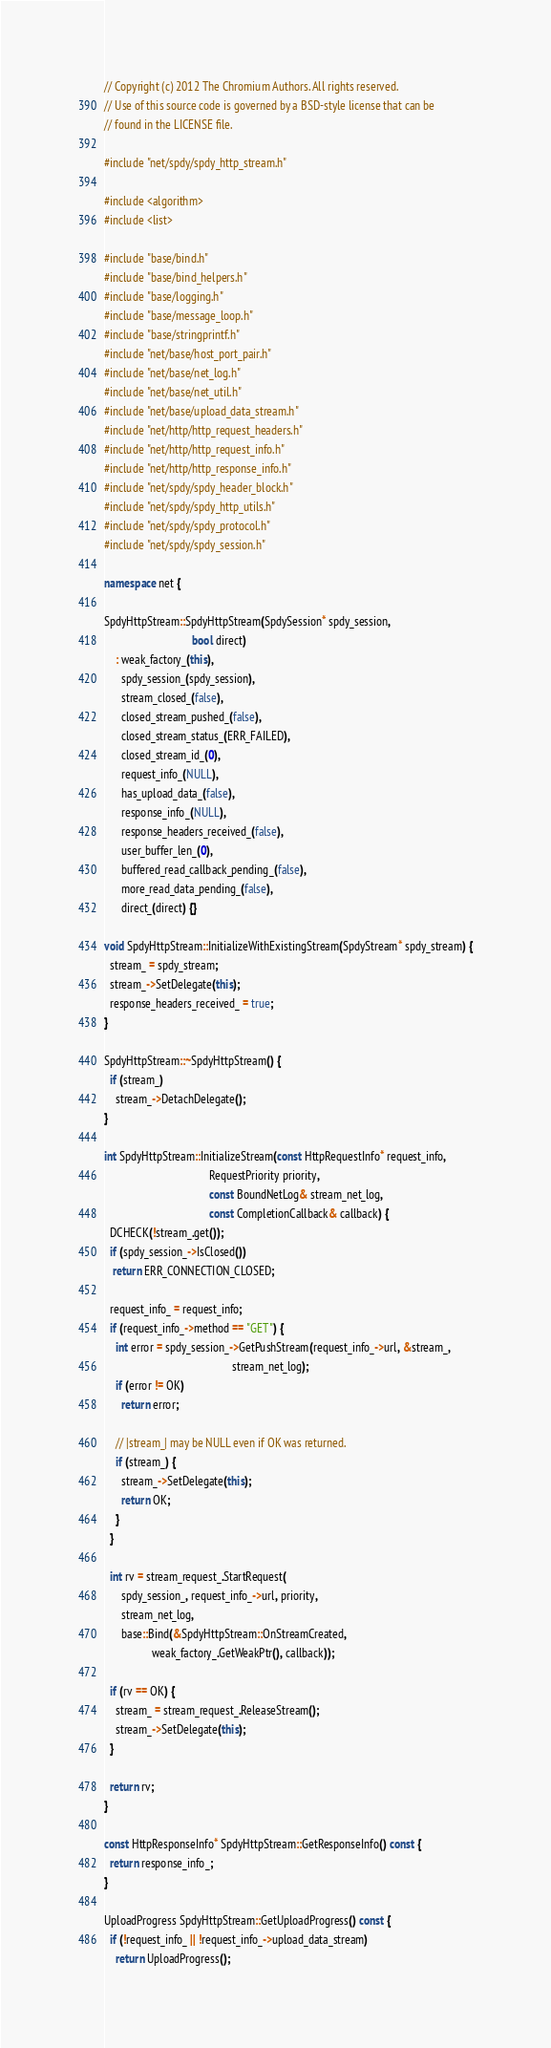<code> <loc_0><loc_0><loc_500><loc_500><_C++_>// Copyright (c) 2012 The Chromium Authors. All rights reserved.
// Use of this source code is governed by a BSD-style license that can be
// found in the LICENSE file.

#include "net/spdy/spdy_http_stream.h"

#include <algorithm>
#include <list>

#include "base/bind.h"
#include "base/bind_helpers.h"
#include "base/logging.h"
#include "base/message_loop.h"
#include "base/stringprintf.h"
#include "net/base/host_port_pair.h"
#include "net/base/net_log.h"
#include "net/base/net_util.h"
#include "net/base/upload_data_stream.h"
#include "net/http/http_request_headers.h"
#include "net/http/http_request_info.h"
#include "net/http/http_response_info.h"
#include "net/spdy/spdy_header_block.h"
#include "net/spdy/spdy_http_utils.h"
#include "net/spdy/spdy_protocol.h"
#include "net/spdy/spdy_session.h"

namespace net {

SpdyHttpStream::SpdyHttpStream(SpdySession* spdy_session,
                               bool direct)
    : weak_factory_(this),
      spdy_session_(spdy_session),
      stream_closed_(false),
      closed_stream_pushed_(false),
      closed_stream_status_(ERR_FAILED),
      closed_stream_id_(0),
      request_info_(NULL),
      has_upload_data_(false),
      response_info_(NULL),
      response_headers_received_(false),
      user_buffer_len_(0),
      buffered_read_callback_pending_(false),
      more_read_data_pending_(false),
      direct_(direct) {}

void SpdyHttpStream::InitializeWithExistingStream(SpdyStream* spdy_stream) {
  stream_ = spdy_stream;
  stream_->SetDelegate(this);
  response_headers_received_ = true;
}

SpdyHttpStream::~SpdyHttpStream() {
  if (stream_)
    stream_->DetachDelegate();
}

int SpdyHttpStream::InitializeStream(const HttpRequestInfo* request_info,
                                     RequestPriority priority,
                                     const BoundNetLog& stream_net_log,
                                     const CompletionCallback& callback) {
  DCHECK(!stream_.get());
  if (spdy_session_->IsClosed())
   return ERR_CONNECTION_CLOSED;

  request_info_ = request_info;
  if (request_info_->method == "GET") {
    int error = spdy_session_->GetPushStream(request_info_->url, &stream_,
                                             stream_net_log);
    if (error != OK)
      return error;

    // |stream_| may be NULL even if OK was returned.
    if (stream_) {
      stream_->SetDelegate(this);
      return OK;
    }
  }

  int rv = stream_request_.StartRequest(
      spdy_session_, request_info_->url, priority,
      stream_net_log,
      base::Bind(&SpdyHttpStream::OnStreamCreated,
                 weak_factory_.GetWeakPtr(), callback));

  if (rv == OK) {
    stream_ = stream_request_.ReleaseStream();
    stream_->SetDelegate(this);
  }

  return rv;
}

const HttpResponseInfo* SpdyHttpStream::GetResponseInfo() const {
  return response_info_;
}

UploadProgress SpdyHttpStream::GetUploadProgress() const {
  if (!request_info_ || !request_info_->upload_data_stream)
    return UploadProgress();
</code> 